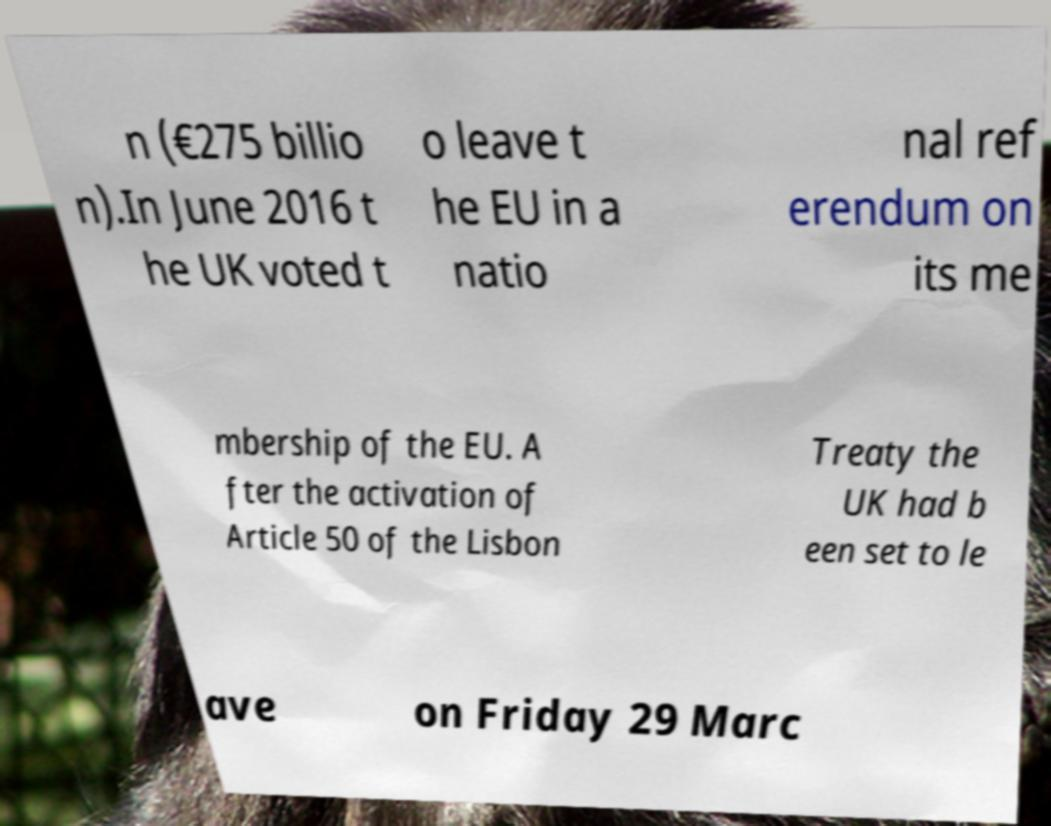What messages or text are displayed in this image? I need them in a readable, typed format. n (€275 billio n).In June 2016 t he UK voted t o leave t he EU in a natio nal ref erendum on its me mbership of the EU. A fter the activation of Article 50 of the Lisbon Treaty the UK had b een set to le ave on Friday 29 Marc 